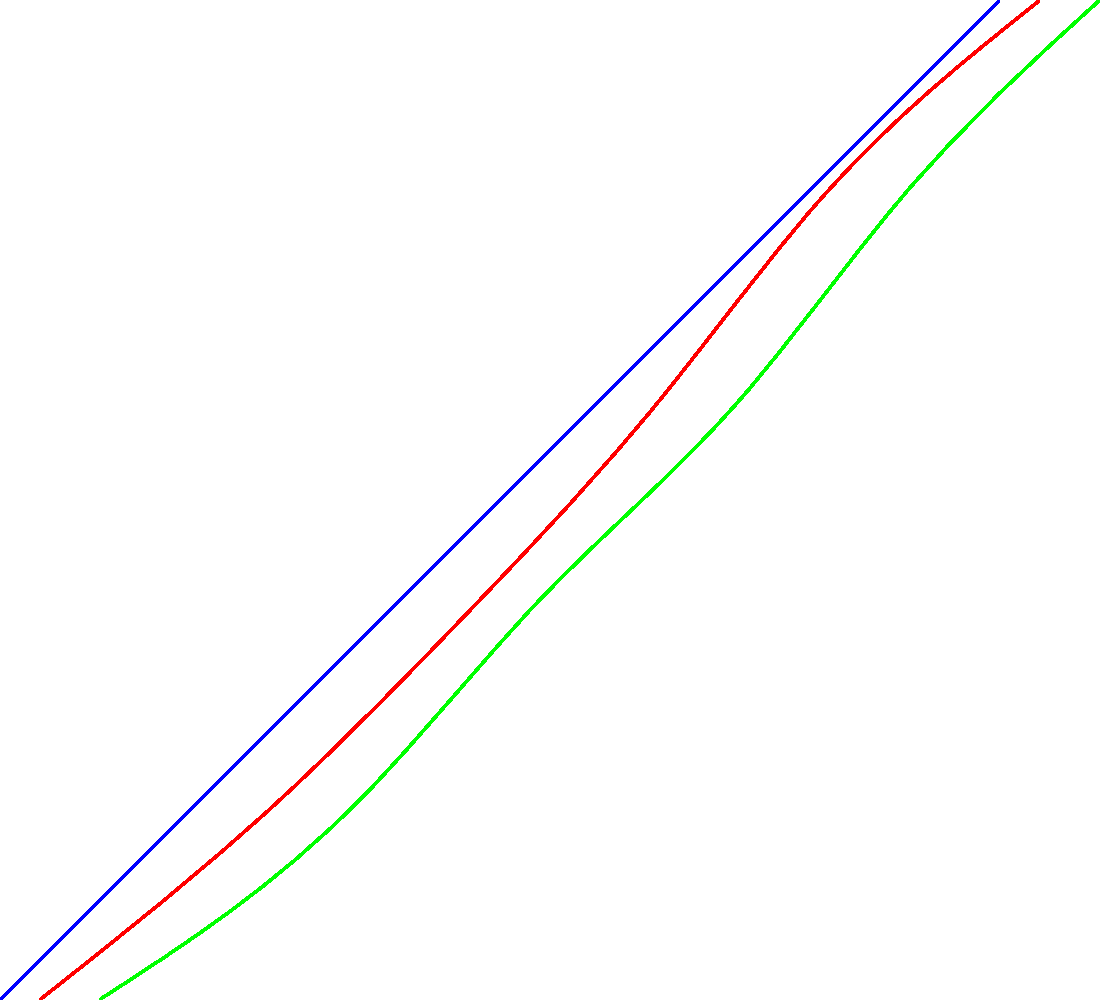Based on the comparative chart of modus operandi for Ted Bundy, Jeffrey Dahmer, and John Wayne Gacy, which criminal exhibited the most distinct geographic pattern in their crimes, and how does this relate to their overall victim count? To answer this question, we need to analyze the chart and compare the "Geographic Pattern" and "Victim Count" for each criminal:

1. Ted Bundy (Blue line):
   - Geographic Pattern: Approximately 4 on the scale
   - Victim Count: Approximately 5 on the scale

2. Jeffrey Dahmer (Red line):
   - Geographic Pattern: Approximately 4.1 on the scale
   - Victim Count: Approximately 5.2 on the scale

3. John Wayne Gacy (Green line):
   - Geographic Pattern: Approximately 4.5 on the scale
   - Victim Count: Approximately 5.5 on the scale

Analyzing these data points:

1. Ted Bundy had the lowest score for geographic pattern, suggesting he had the widest range of locations for his crimes. This aligns with historical accounts of Bundy operating across multiple states.

2. Jeffrey Dahmer's geographic pattern score is slightly higher than Bundy's, indicating a somewhat more localized area of operation.

3. John Wayne Gacy has the highest geographic pattern score, suggesting his crimes were the most geographically concentrated.

Regarding victim count, all three criminals have high scores, but Gacy's is the highest, followed closely by Dahmer, then Bundy.

The relationship between geographic pattern and victim count appears to be positively correlated in this case. Gacy, with the most localized geographic pattern, also has the highest victim count. This could suggest that operating in a more confined area allowed him to claim more victims without drawing attention from multiple jurisdictions.

In contrast, Bundy's wider geographic range might have contributed to a slightly lower victim count, as he had to move between locations more frequently, potentially limiting his opportunities.
Answer: John Wayne Gacy exhibited the most distinct geographic pattern, correlating with the highest victim count, suggesting a localized operation facilitated more crimes. 